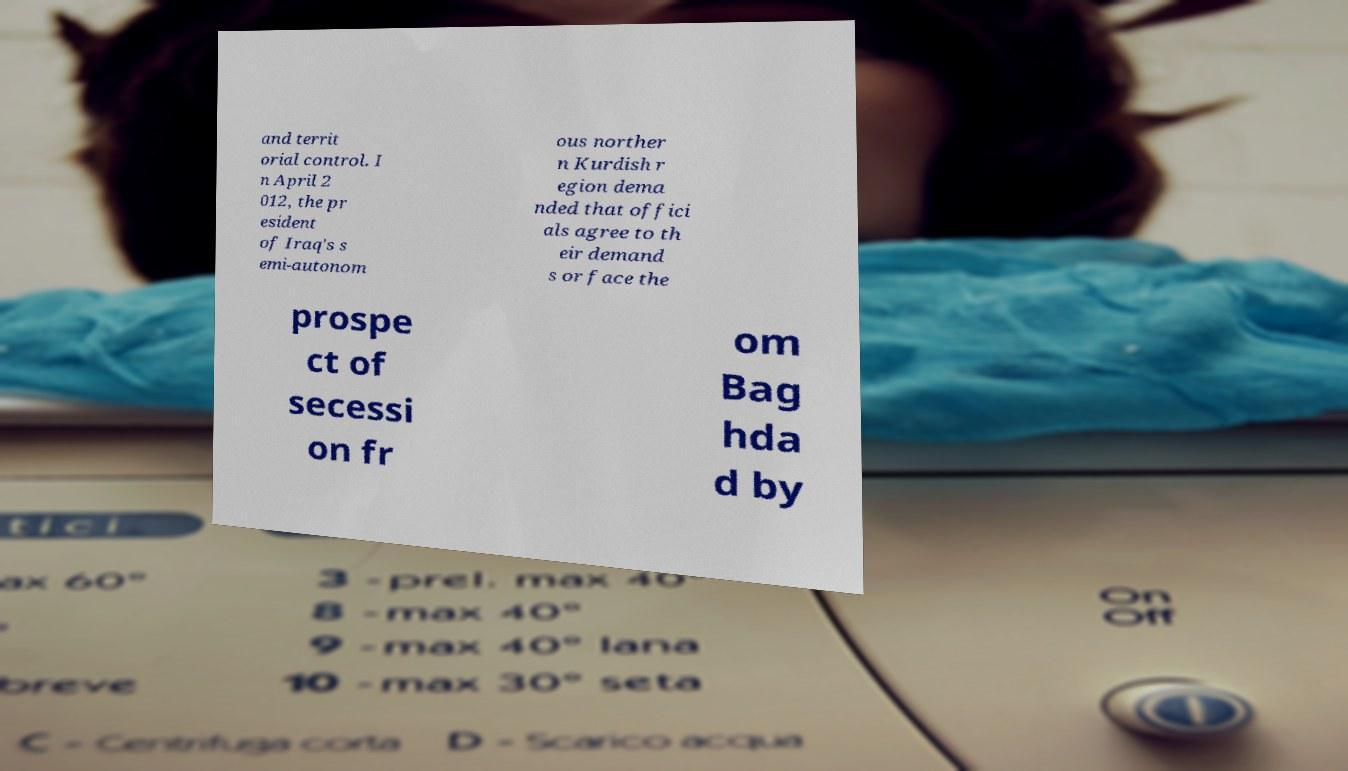What messages or text are displayed in this image? I need them in a readable, typed format. and territ orial control. I n April 2 012, the pr esident of Iraq's s emi-autonom ous norther n Kurdish r egion dema nded that offici als agree to th eir demand s or face the prospe ct of secessi on fr om Bag hda d by 